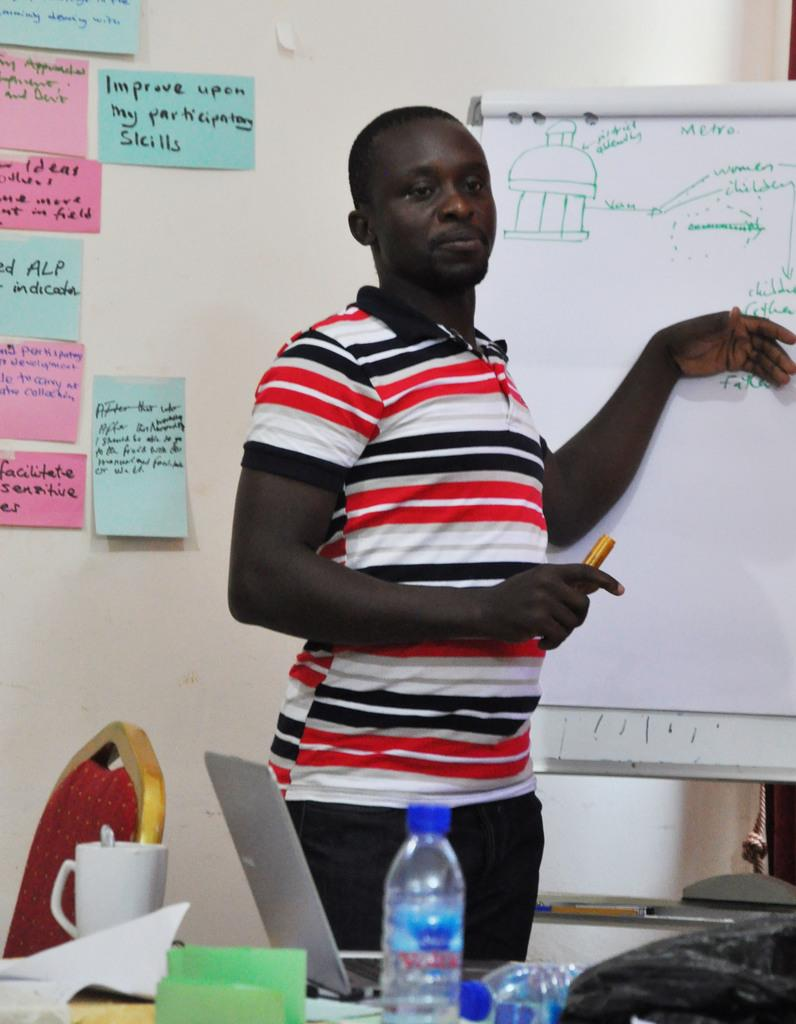<image>
Relay a brief, clear account of the picture shown. a note on the wall that says skills on it 